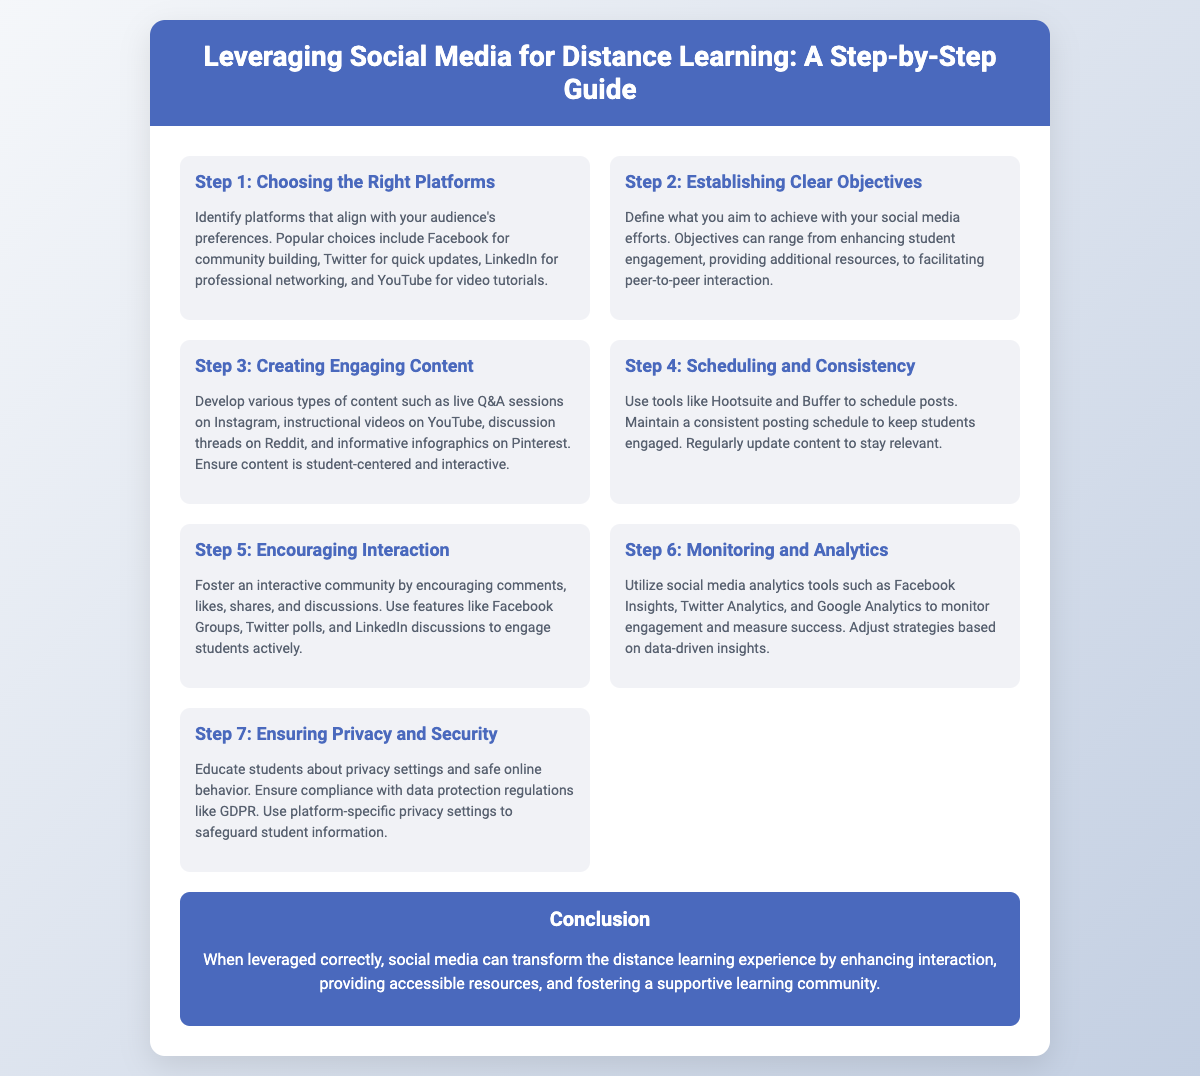What is the first step in leveraging social media for distance learning? The first step outlined in the presentation is "Choosing the Right Platforms."
Answer: Choosing the Right Platforms What type of content should be created for distance learning? The presentation suggests developing various types of content, including live Q&A sessions, instructional videos, discussion threads, and infographics.
Answer: Engaging content Which tools can be used for scheduling posts? The document mentions using tools like Hootsuite and Buffer for scheduling posts.
Answer: Hootsuite and Buffer What is the last step mentioned in the guide? The final step in the guide is "Ensuring Privacy and Security."
Answer: Ensuring Privacy and Security What is the conclusion about social media's role in distance learning? The conclusion states that social media can transform the distance learning experience by enhancing interaction and fostering a supportive learning community.
Answer: Transform the distance learning experience How many steps are outlined in the guide? The presentation lists a total of seven steps for leveraging social media for distance learning.
Answer: Seven steps What is the purpose of monitoring and analytics in social media? Monitoring and analytics are used to measure engagement and success in social media efforts.
Answer: Measure engagement and success Which social media feature encourages interaction according to the document? The document highlights using features like Facebook Groups and Twitter polls to promote interaction.
Answer: Facebook Groups and Twitter polls What types of platforms are suggested for community building? Popular platforms recommended for community building include Facebook, Twitter, and LinkedIn.
Answer: Facebook, Twitter, and LinkedIn 